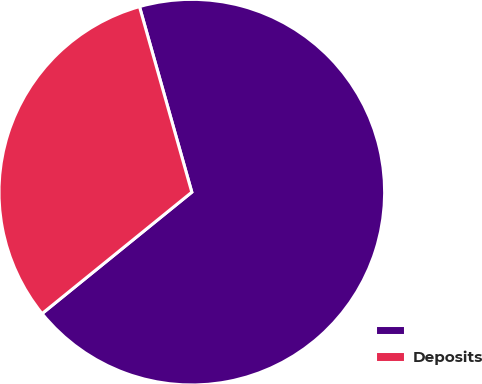Convert chart. <chart><loc_0><loc_0><loc_500><loc_500><pie_chart><ecel><fcel>Deposits<nl><fcel>68.53%<fcel>31.47%<nl></chart> 